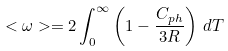<formula> <loc_0><loc_0><loc_500><loc_500>< \omega > = 2 \int _ { 0 } ^ { \infty } \left ( 1 - \frac { C _ { p h } } { 3 R } \right ) \, d T</formula> 